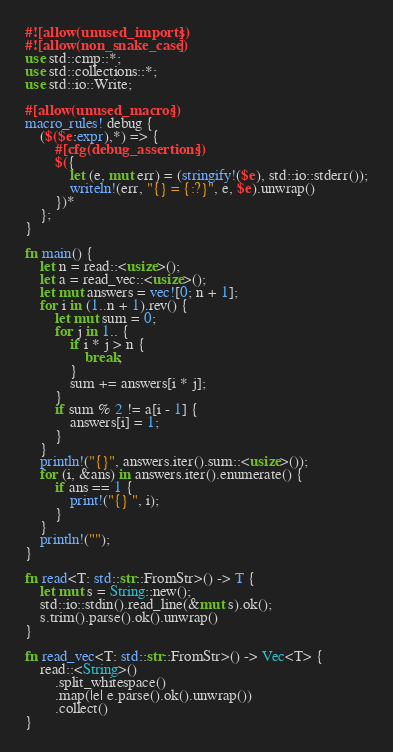<code> <loc_0><loc_0><loc_500><loc_500><_Rust_>#![allow(unused_imports)]
#![allow(non_snake_case)]
use std::cmp::*;
use std::collections::*;
use std::io::Write;

#[allow(unused_macros)]
macro_rules! debug {
    ($($e:expr),*) => {
        #[cfg(debug_assertions)]
        $({
            let (e, mut err) = (stringify!($e), std::io::stderr());
            writeln!(err, "{} = {:?}", e, $e).unwrap()
        })*
    };
}

fn main() {
    let n = read::<usize>();
    let a = read_vec::<usize>();
    let mut answers = vec![0; n + 1];
    for i in (1..n + 1).rev() {
        let mut sum = 0;
        for j in 1.. {
            if i * j > n {
                break;
            }
            sum += answers[i * j];
        }
        if sum % 2 != a[i - 1] {
            answers[i] = 1;
        }
    }
    println!("{}", answers.iter().sum::<usize>());
    for (i, &ans) in answers.iter().enumerate() {
        if ans == 1 {
            print!("{} ", i);
        }
    }
    println!("");
}

fn read<T: std::str::FromStr>() -> T {
    let mut s = String::new();
    std::io::stdin().read_line(&mut s).ok();
    s.trim().parse().ok().unwrap()
}

fn read_vec<T: std::str::FromStr>() -> Vec<T> {
    read::<String>()
        .split_whitespace()
        .map(|e| e.parse().ok().unwrap())
        .collect()
}
</code> 